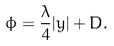Convert formula to latex. <formula><loc_0><loc_0><loc_500><loc_500>\phi = \frac { \lambda } { 4 } | y | + D .</formula> 